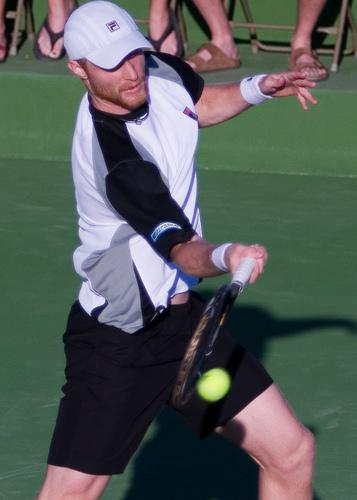Question: what is he doing?
Choices:
A. Playing.
B. Fighting.
C. Sleeping.
D. Studying.
Answer with the letter. Answer: A Question: why is he standing?
Choices:
A. He is tired of sitting.
B. To sleep.
C. To hit the ball.
D. To go to the store.
Answer with the letter. Answer: C Question: how is the photo?
Choices:
A. Clear.
B. Blank.
C. Black and white.
D. Blurry.
Answer with the letter. Answer: D Question: what color is the pitch?
Choices:
A. Black.
B. Yellow.
C. Green.
D. Red.
Answer with the letter. Answer: C Question: where was this photo taken?
Choices:
A. At a tennis game.
B. At the beach.
C. In Paris.
D. At the park.
Answer with the letter. Answer: A 